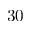Convert formula to latex. <formula><loc_0><loc_0><loc_500><loc_500>3 0</formula> 